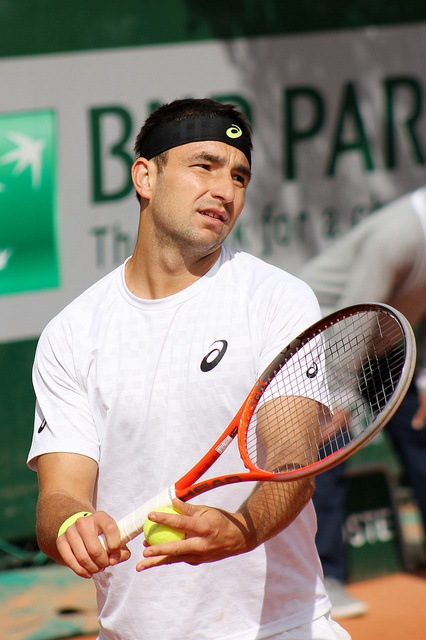Describe the objects in this image and their specific colors. I can see people in darkgreen, lavender, tan, salmon, and darkgray tones, tennis racket in darkgreen, lightgray, darkgray, black, and gray tones, people in darkgreen, darkgray, maroon, black, and gray tones, and sports ball in darkgreen, khaki, and olive tones in this image. 